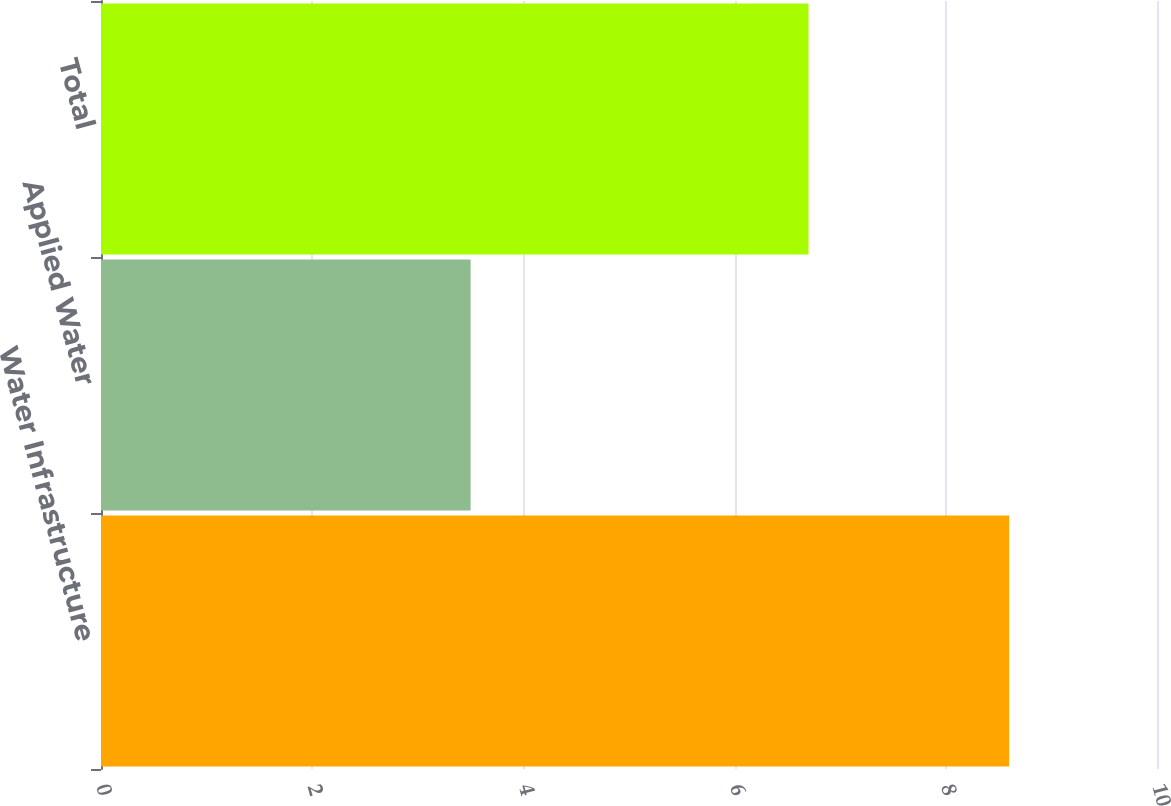Convert chart to OTSL. <chart><loc_0><loc_0><loc_500><loc_500><bar_chart><fcel>Water Infrastructure<fcel>Applied Water<fcel>Total<nl><fcel>8.6<fcel>3.5<fcel>6.7<nl></chart> 